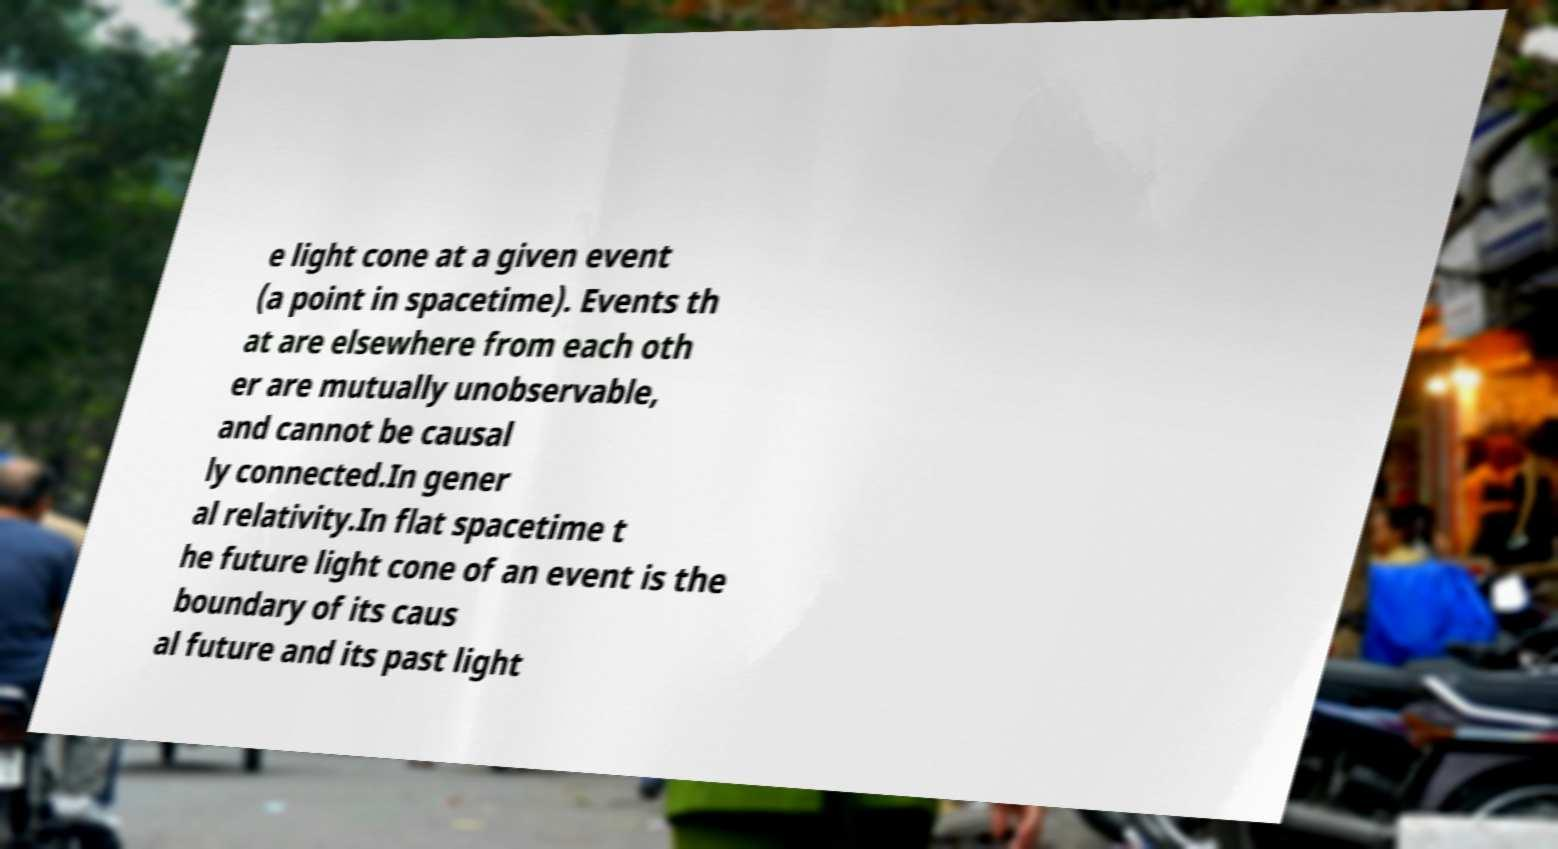Please identify and transcribe the text found in this image. e light cone at a given event (a point in spacetime). Events th at are elsewhere from each oth er are mutually unobservable, and cannot be causal ly connected.In gener al relativity.In flat spacetime t he future light cone of an event is the boundary of its caus al future and its past light 